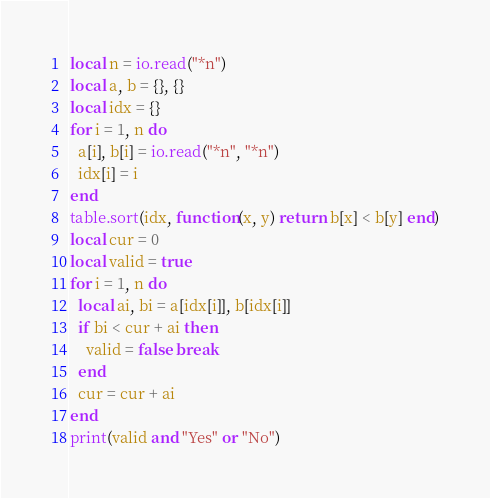Convert code to text. <code><loc_0><loc_0><loc_500><loc_500><_Lua_>local n = io.read("*n")
local a, b = {}, {}
local idx = {}
for i = 1, n do
  a[i], b[i] = io.read("*n", "*n")
  idx[i] = i
end
table.sort(idx, function(x, y) return b[x] < b[y] end)
local cur = 0
local valid = true
for i = 1, n do
  local ai, bi = a[idx[i]], b[idx[i]]
  if bi < cur + ai then
    valid = false break
  end
  cur = cur + ai
end
print(valid and "Yes" or "No")
</code> 